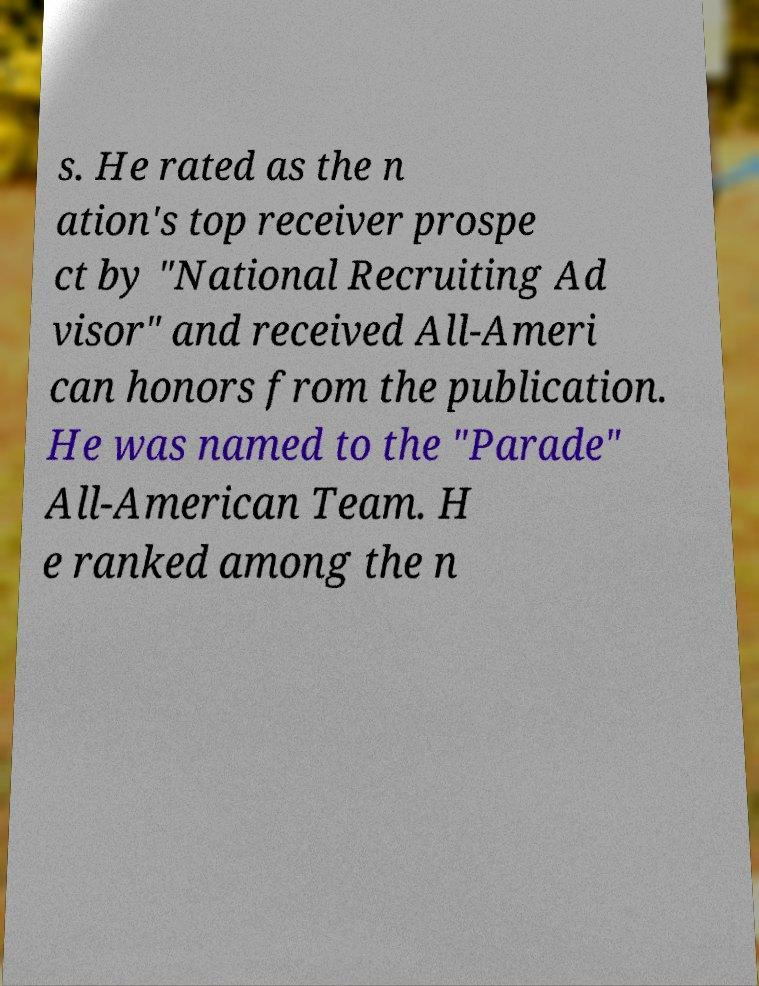There's text embedded in this image that I need extracted. Can you transcribe it verbatim? s. He rated as the n ation's top receiver prospe ct by "National Recruiting Ad visor" and received All-Ameri can honors from the publication. He was named to the "Parade" All-American Team. H e ranked among the n 